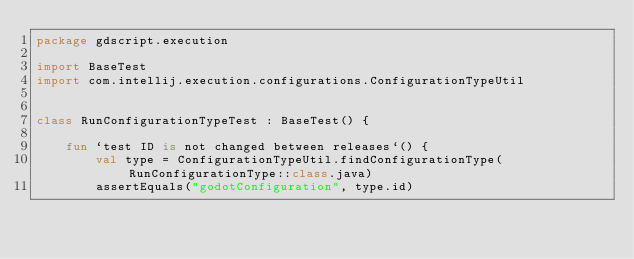Convert code to text. <code><loc_0><loc_0><loc_500><loc_500><_Kotlin_>package gdscript.execution

import BaseTest
import com.intellij.execution.configurations.ConfigurationTypeUtil


class RunConfigurationTypeTest : BaseTest() {

    fun `test ID is not changed between releases`() {
        val type = ConfigurationTypeUtil.findConfigurationType(RunConfigurationType::class.java)
        assertEquals("godotConfiguration", type.id)</code> 